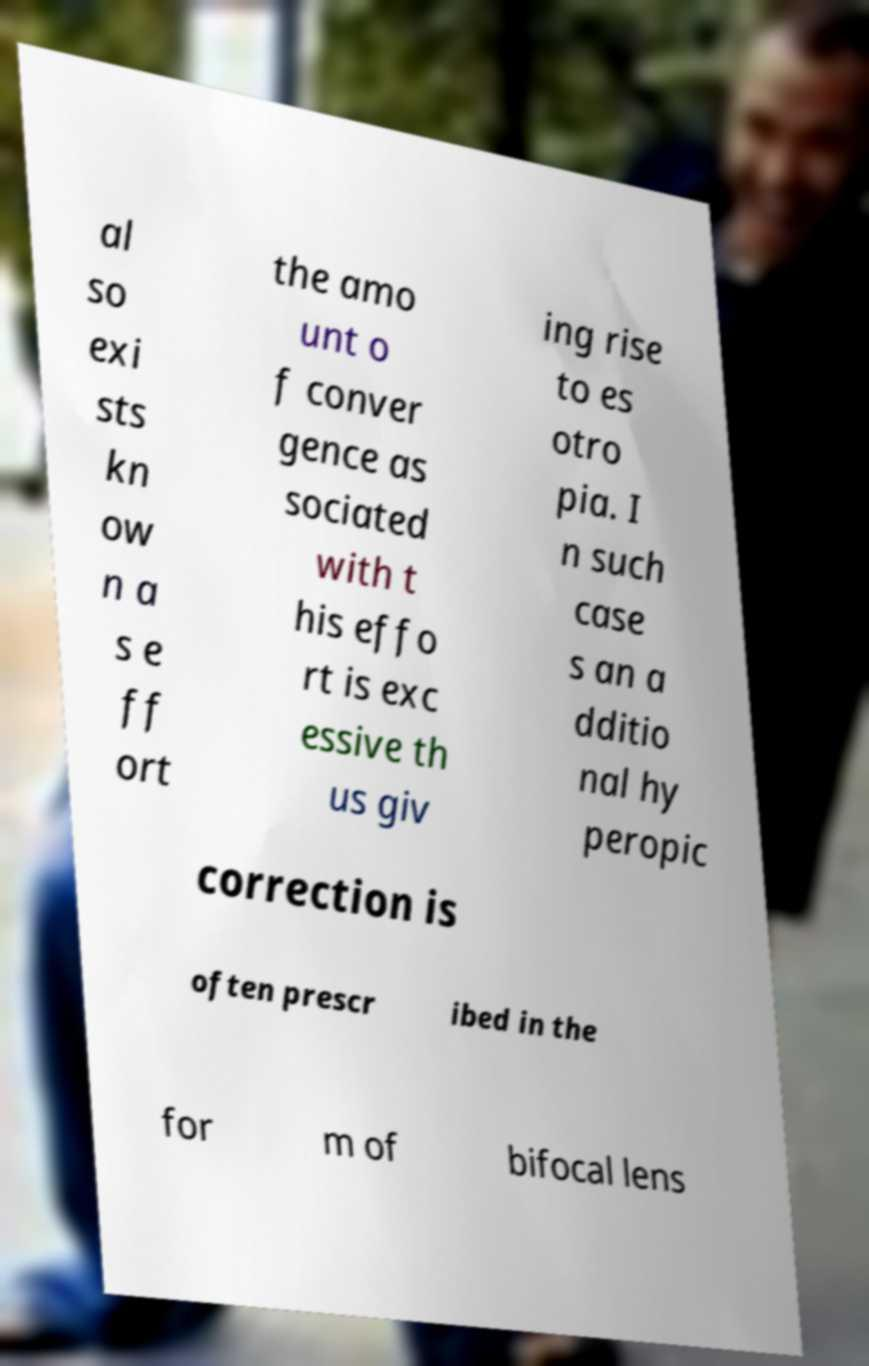Can you accurately transcribe the text from the provided image for me? al so exi sts kn ow n a s e ff ort the amo unt o f conver gence as sociated with t his effo rt is exc essive th us giv ing rise to es otro pia. I n such case s an a dditio nal hy peropic correction is often prescr ibed in the for m of bifocal lens 